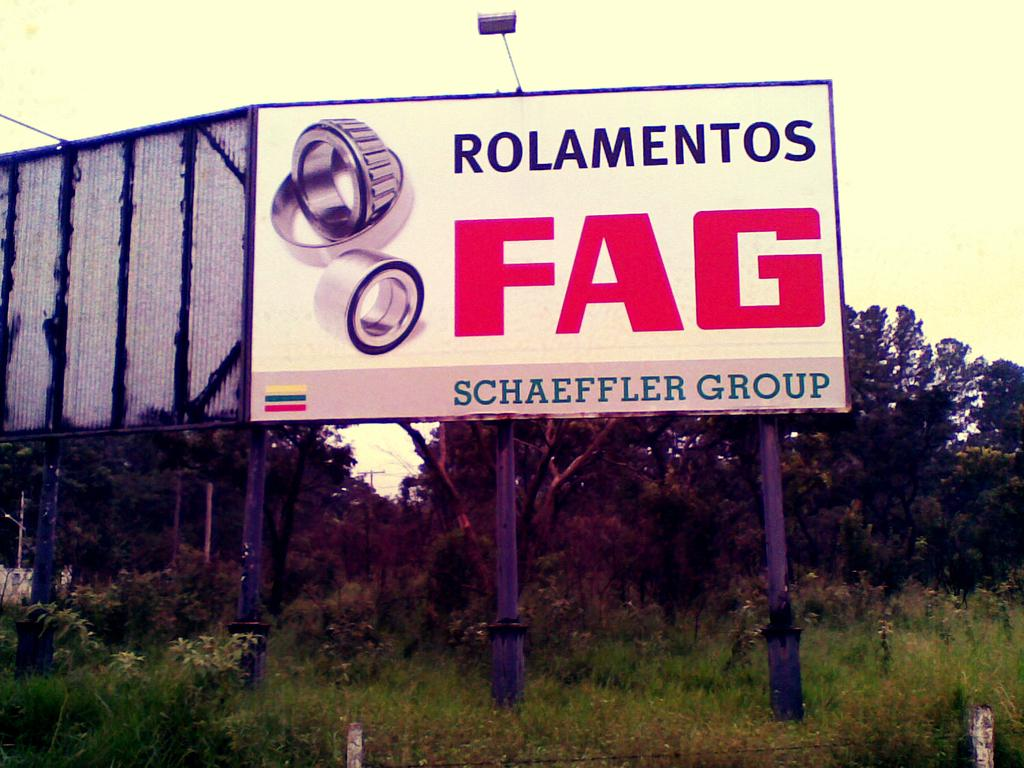Provide a one-sentence caption for the provided image. A poster advertises the FAG brand in large red letters. 